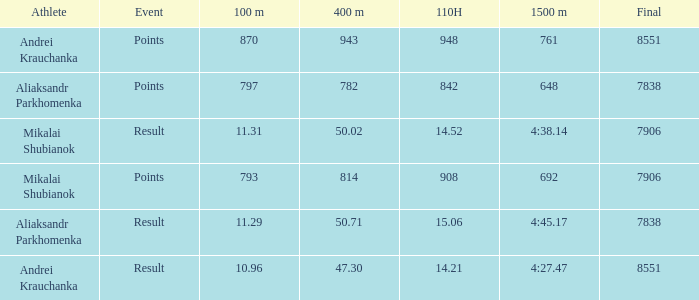What was the 100m that the 110H was less than 14.52 and the 400m was more than 47.3? None. 